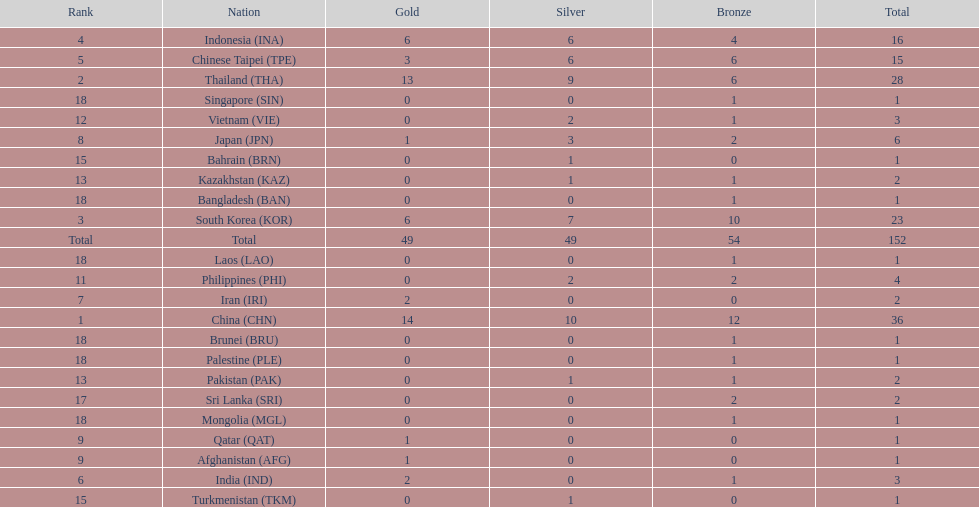Did the philippines or kazakhstan have a higher number of total medals? Philippines. 